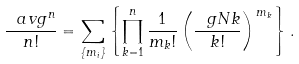Convert formula to latex. <formula><loc_0><loc_0><loc_500><loc_500>\frac { \ a v { g ^ { n } } } { n ! } = \sum _ { \{ m _ { i } \} } \left \{ \prod _ { k = 1 } ^ { n } \frac { 1 } { m _ { k } ! } \left ( \frac { \ g N k } { k ! } \right ) ^ { \, m _ { k } } \right \} .</formula> 